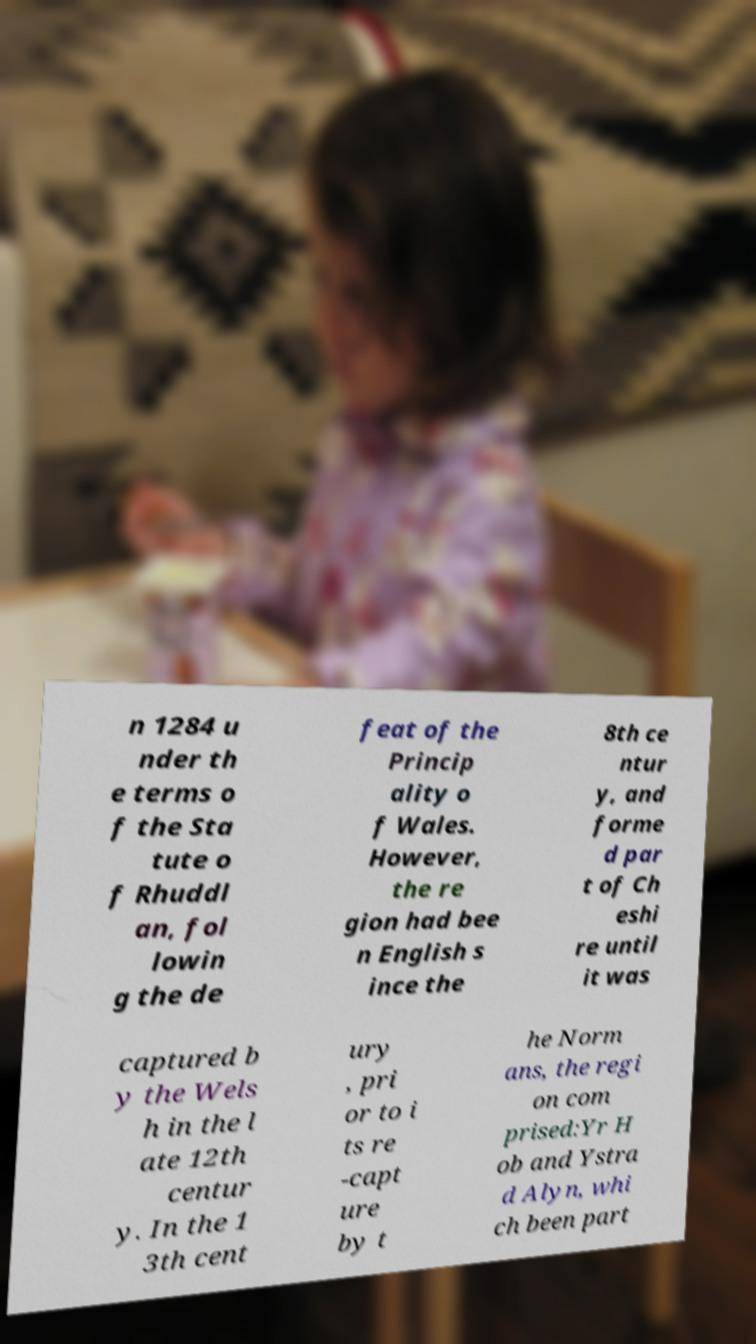What messages or text are displayed in this image? I need them in a readable, typed format. n 1284 u nder th e terms o f the Sta tute o f Rhuddl an, fol lowin g the de feat of the Princip ality o f Wales. However, the re gion had bee n English s ince the 8th ce ntur y, and forme d par t of Ch eshi re until it was captured b y the Wels h in the l ate 12th centur y. In the 1 3th cent ury , pri or to i ts re -capt ure by t he Norm ans, the regi on com prised:Yr H ob and Ystra d Alyn, whi ch been part 